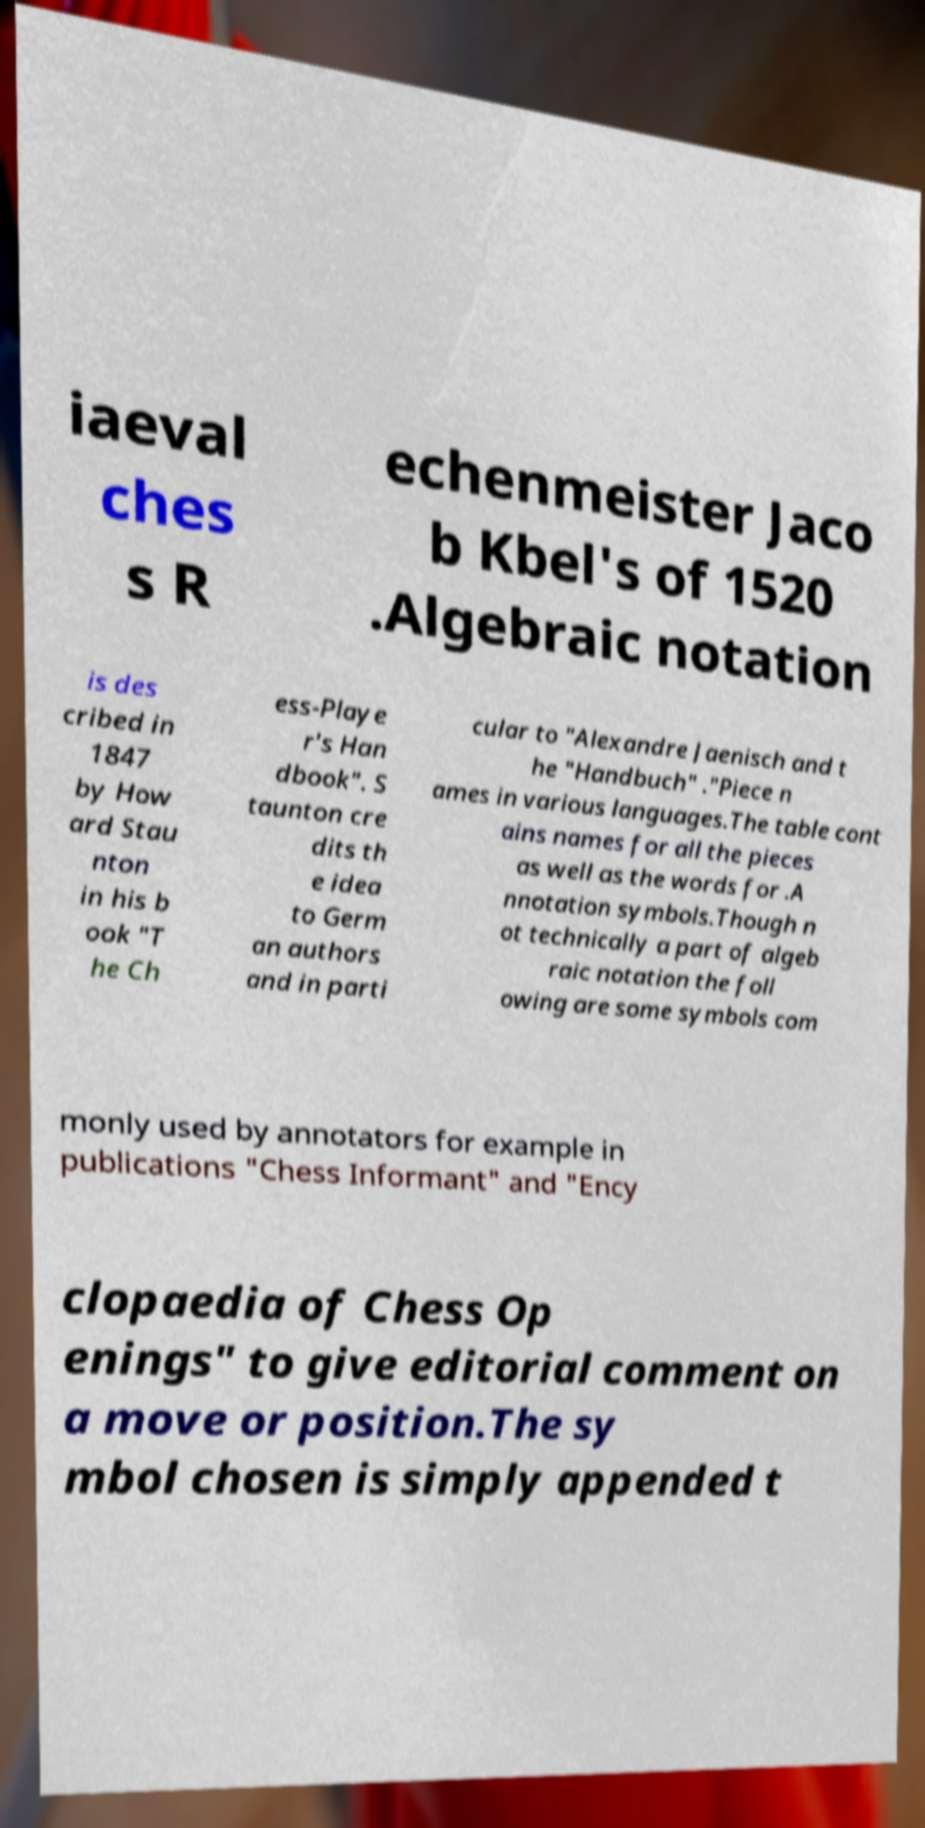I need the written content from this picture converted into text. Can you do that? iaeval ches s R echenmeister Jaco b Kbel's of 1520 .Algebraic notation is des cribed in 1847 by How ard Stau nton in his b ook "T he Ch ess-Playe r's Han dbook". S taunton cre dits th e idea to Germ an authors and in parti cular to "Alexandre Jaenisch and t he "Handbuch" ."Piece n ames in various languages.The table cont ains names for all the pieces as well as the words for .A nnotation symbols.Though n ot technically a part of algeb raic notation the foll owing are some symbols com monly used by annotators for example in publications "Chess Informant" and "Ency clopaedia of Chess Op enings" to give editorial comment on a move or position.The sy mbol chosen is simply appended t 